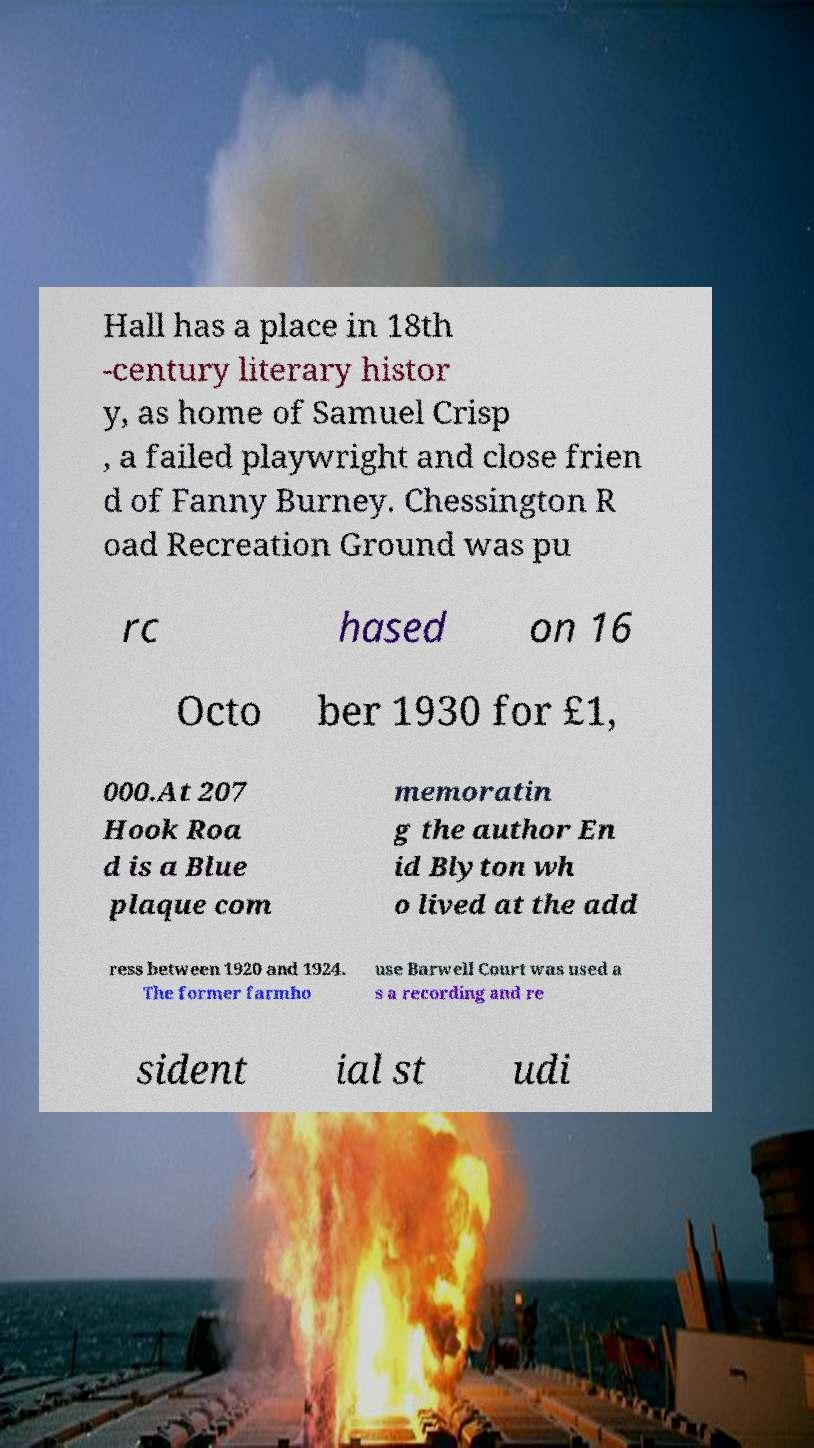I need the written content from this picture converted into text. Can you do that? Hall has a place in 18th -century literary histor y, as home of Samuel Crisp , a failed playwright and close frien d of Fanny Burney. Chessington R oad Recreation Ground was pu rc hased on 16 Octo ber 1930 for £1, 000.At 207 Hook Roa d is a Blue plaque com memoratin g the author En id Blyton wh o lived at the add ress between 1920 and 1924. The former farmho use Barwell Court was used a s a recording and re sident ial st udi 